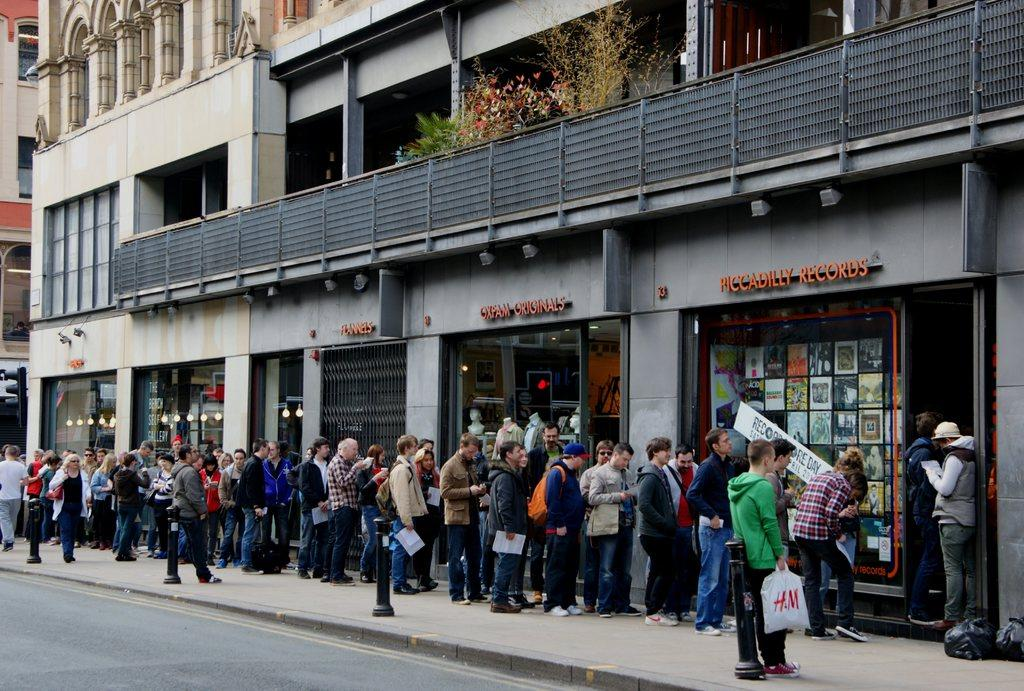<image>
Create a compact narrative representing the image presented. Several stores with people lined up outside them, and the furthest left says Piccadilly Records above it. 